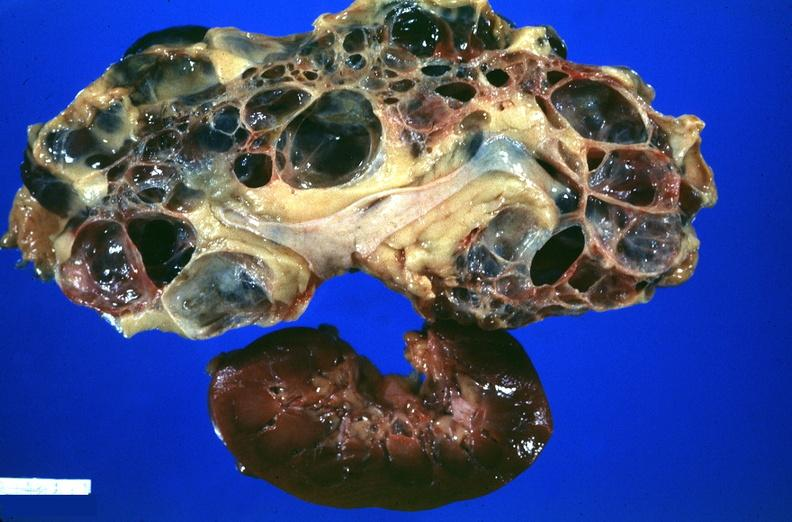does exact cause show kidney, adult polycystic kidney?
Answer the question using a single word or phrase. No 